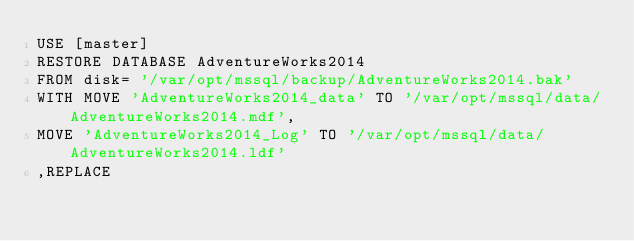Convert code to text. <code><loc_0><loc_0><loc_500><loc_500><_SQL_>USE [master]
RESTORE DATABASE AdventureWorks2014
FROM disk= '/var/opt/mssql/backup/AdventureWorks2014.bak'
WITH MOVE 'AdventureWorks2014_data' TO '/var/opt/mssql/data/AdventureWorks2014.mdf',
MOVE 'AdventureWorks2014_Log' TO '/var/opt/mssql/data/AdventureWorks2014.ldf'
,REPLACE
</code> 